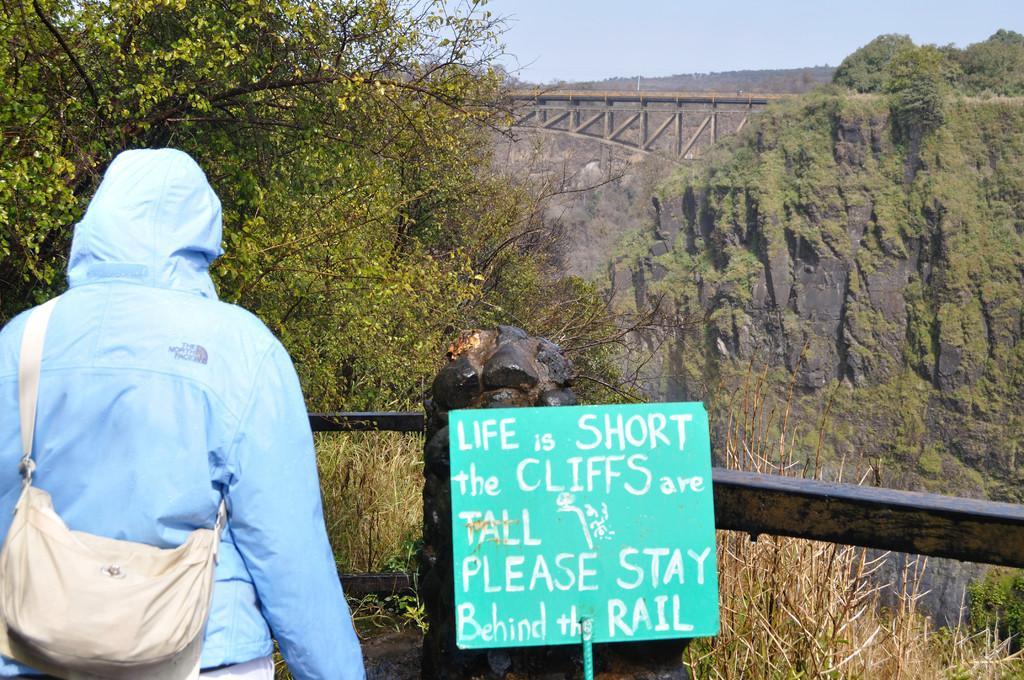Describe this image in one or two sentences. In this image the man is standing on the mountain wearing a blue colour jacket and white colour backpack. In front of him we can see a trees,a mountain,a bridge, sky, mountain with grass, dry grass and a board with a quote written on it Life is short the cliffs are tall please stay behind the rail. 